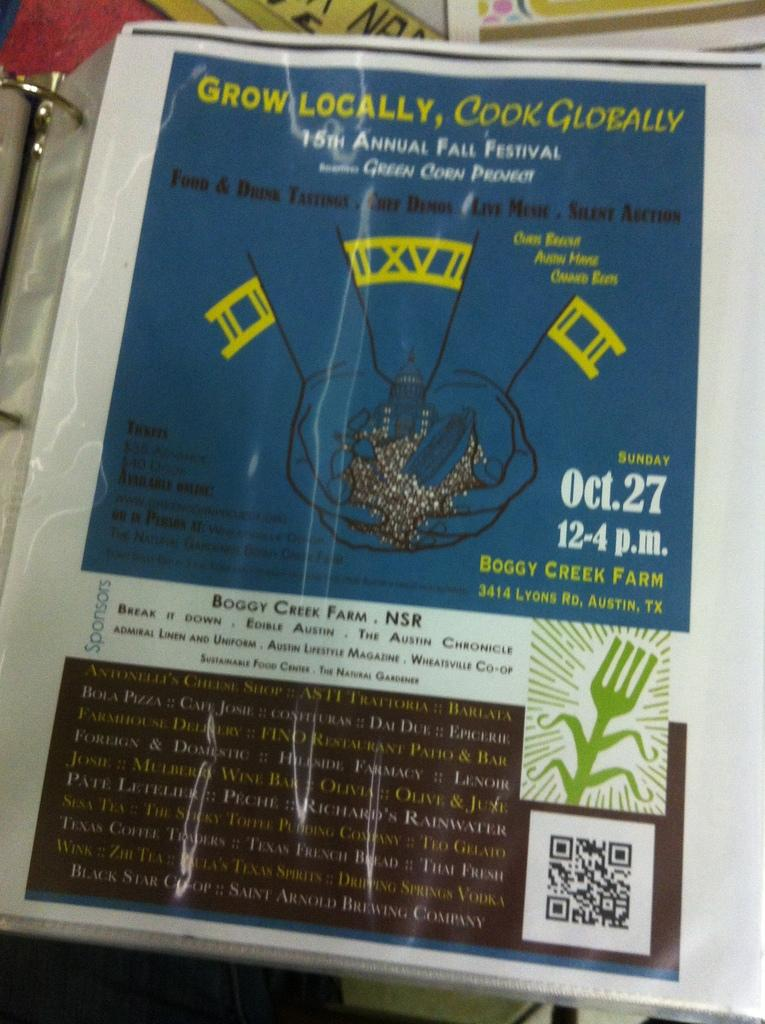<image>
Render a clear and concise summary of the photo. Boggy Creek Farm presents the 15th Annual Fall Festival on Oct 27. 